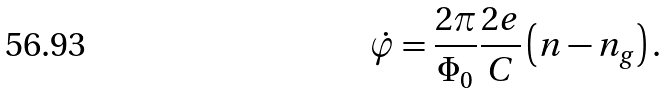<formula> <loc_0><loc_0><loc_500><loc_500>\dot { \varphi } = \frac { 2 \pi } { \Phi _ { 0 } } \frac { 2 e } { C } \left ( n - n _ { g } \right ) .</formula> 